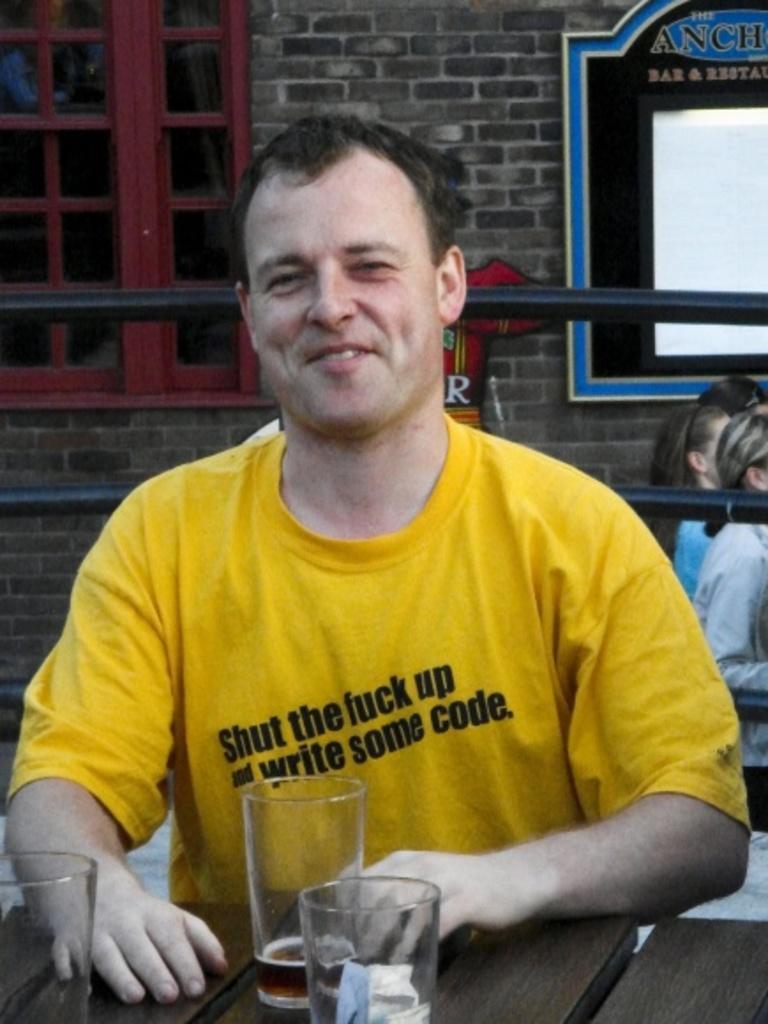How would you summarize this image in a sentence or two? In this image there is a person sitting in-front of table where we can see some glasses, behind him there is a fence and other group of people walking in-front of building. 